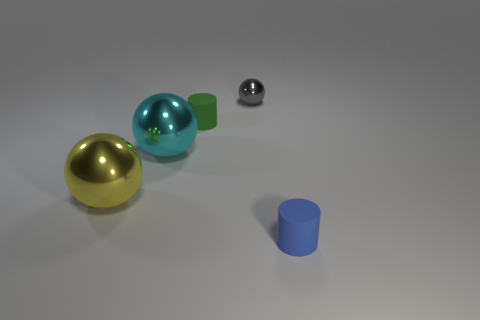What number of objects are small cyan matte blocks or large yellow objects?
Your response must be concise. 1. Is there another blue thing of the same shape as the blue thing?
Your answer should be compact. No. Is the color of the matte cylinder on the left side of the small shiny object the same as the tiny metallic ball?
Provide a succinct answer. No. What shape is the tiny matte thing behind the rubber object that is right of the green object?
Offer a terse response. Cylinder. Are there any yellow spheres that have the same size as the green matte object?
Keep it short and to the point. No. Are there fewer small gray metal objects than gray cylinders?
Your answer should be very brief. No. There is a tiny matte object behind the rubber cylinder right of the rubber object that is behind the blue cylinder; what is its shape?
Keep it short and to the point. Cylinder. What number of things are either cylinders on the right side of the small gray ball or things that are left of the blue matte object?
Keep it short and to the point. 5. Are there any small objects in front of the large cyan metal thing?
Provide a succinct answer. Yes. What number of things are either tiny cylinders behind the blue rubber cylinder or small gray rubber blocks?
Provide a succinct answer. 1. 